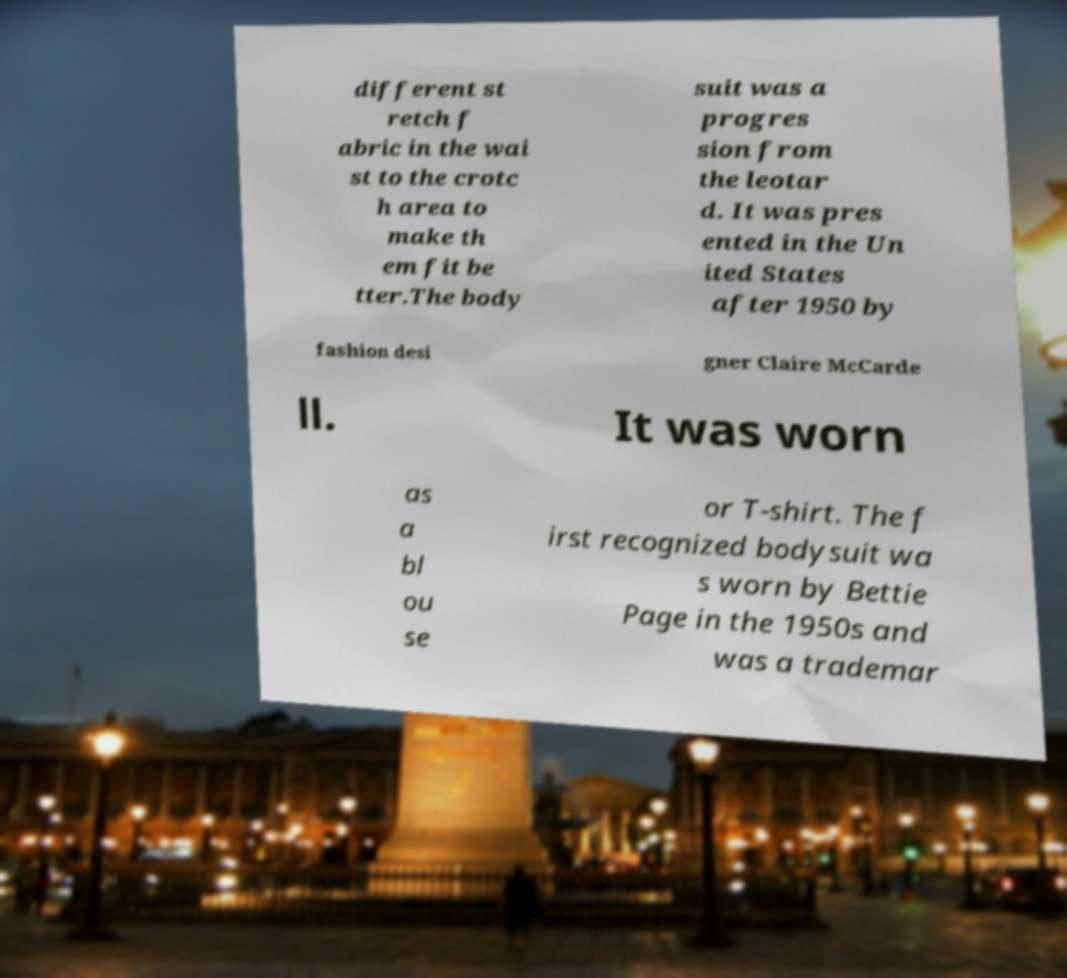For documentation purposes, I need the text within this image transcribed. Could you provide that? different st retch f abric in the wai st to the crotc h area to make th em fit be tter.The body suit was a progres sion from the leotar d. It was pres ented in the Un ited States after 1950 by fashion desi gner Claire McCarde ll. It was worn as a bl ou se or T-shirt. The f irst recognized bodysuit wa s worn by Bettie Page in the 1950s and was a trademar 